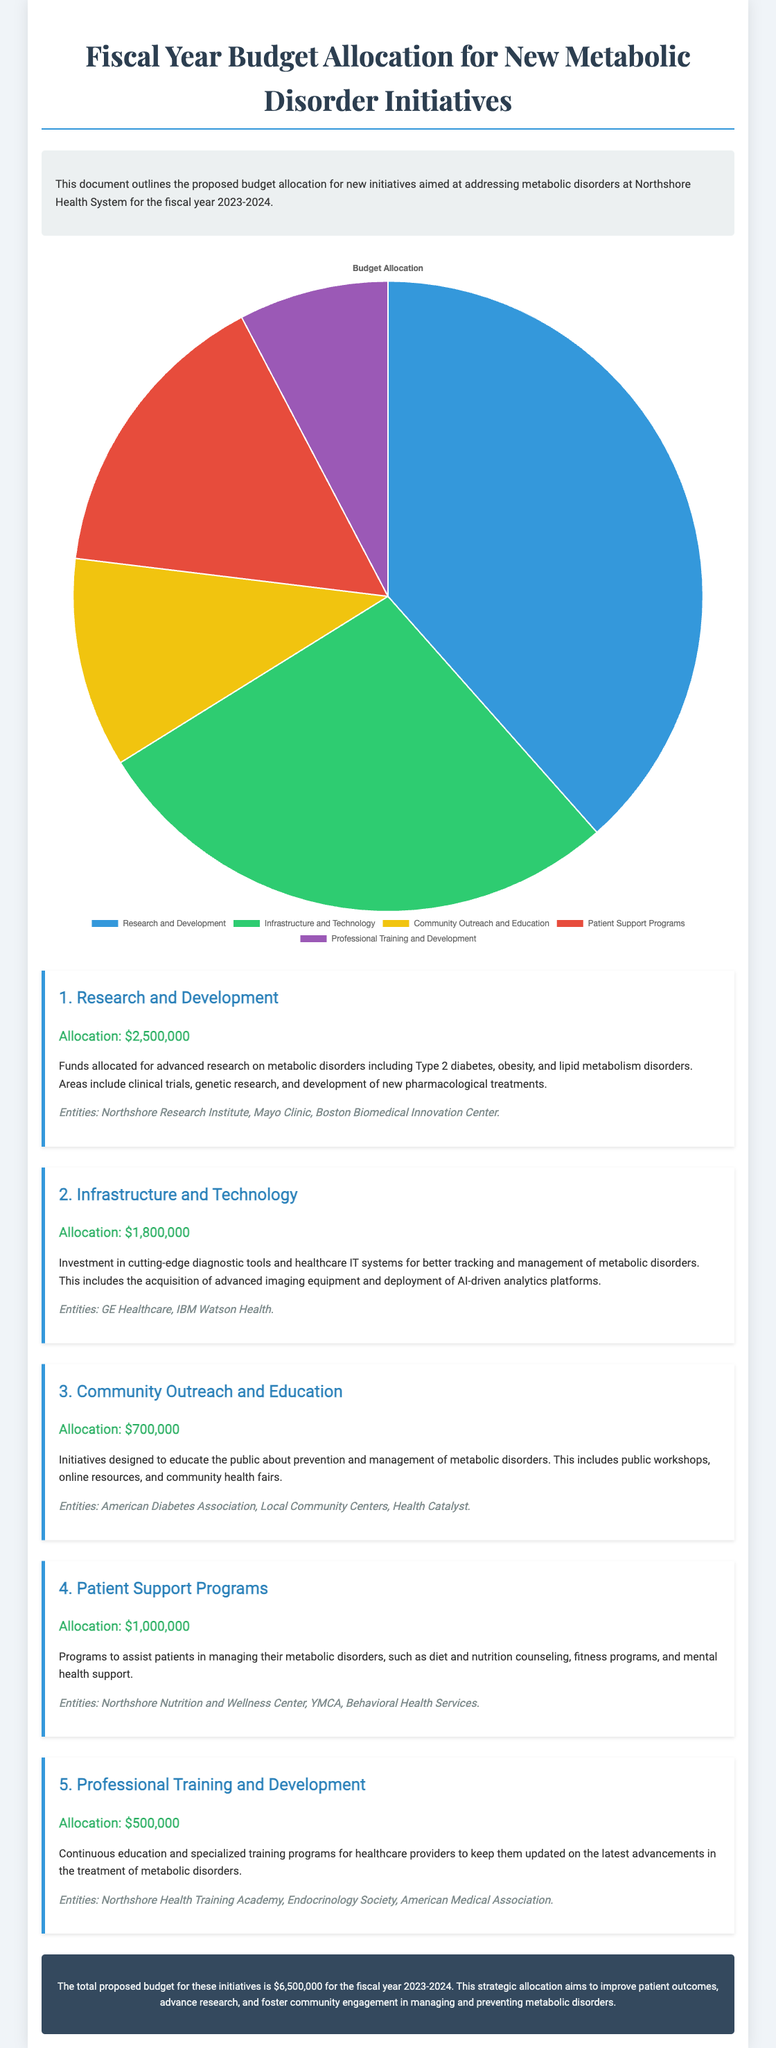What is the total proposed budget? The total proposed budget is stated in the summary at the bottom of the document.
Answer: $6,500,000 How much is allocated for Research and Development? The allocation for Research and Development is specified in the first section of the document.
Answer: $2,500,000 Which entity is associated with Community Outreach and Education? The entities mentioned in the Community Outreach and Education section provide specific organizations involved.
Answer: American Diabetes Association What percentage of the budget is allocated to Infrastructure and Technology? To determine the percentage, compare the allocation for Infrastructure and Technology to the total proposed budget.
Answer: 27.69% Which section has the lowest budget allocation? By reviewing each section's budget allocation, you can identify the one with the smallest amount.
Answer: Professional Training and Development What is the purpose of Patient Support Programs? The document provides a brief description under the Patient Support Programs section explaining its focus.
Answer: Assisting patients in managing their metabolic disorders How many initiatives are listed in the document? Count the numbered sections in the document to find the total number of initiatives discussed.
Answer: 5 What is the main goal of the budget allocation? The footer summarizes the overarching aim of the proposed budget.
Answer: Improve patient outcomes What is the allocation for Community Outreach and Education? The document specifies the budget for this initiative in its dedicated section.
Answer: $700,000 Which technology entity is mentioned in the Infrastructure and Technology section? The section lists the entities involved in this area, allowing for identification.
Answer: IBM Watson Health 